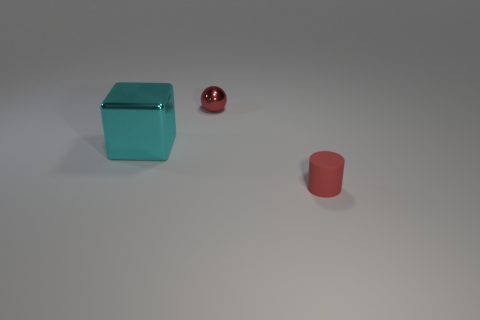What color is the tiny thing that is left of the small red object that is in front of the tiny sphere?
Your answer should be very brief. Red. What number of shiny objects are cylinders or big red things?
Offer a terse response. 0. Does the tiny object left of the rubber thing have the same material as the big cyan block that is on the left side of the red metallic thing?
Offer a very short reply. Yes. Are any small rubber cylinders visible?
Your answer should be compact. Yes. Is there a tiny red thing made of the same material as the big cyan block?
Make the answer very short. Yes. Do the red object behind the big shiny object and the cyan block have the same material?
Your answer should be very brief. Yes. Are there more things on the right side of the large cyan object than red things to the left of the cylinder?
Make the answer very short. Yes. There is a rubber thing that is the same size as the red shiny sphere; what color is it?
Make the answer very short. Red. Is there a thing that has the same color as the shiny ball?
Give a very brief answer. Yes. There is a small thing that is on the right side of the small red ball; is it the same color as the tiny object that is left of the matte object?
Your answer should be compact. Yes. 